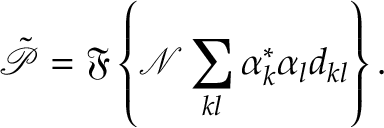<formula> <loc_0><loc_0><loc_500><loc_500>\tilde { \mathcal { P } } = \mathfrak { F } \left \{ \mathcal { N } \sum _ { k l } \alpha _ { k } ^ { * } \alpha _ { l } d _ { k l } \right \} .</formula> 